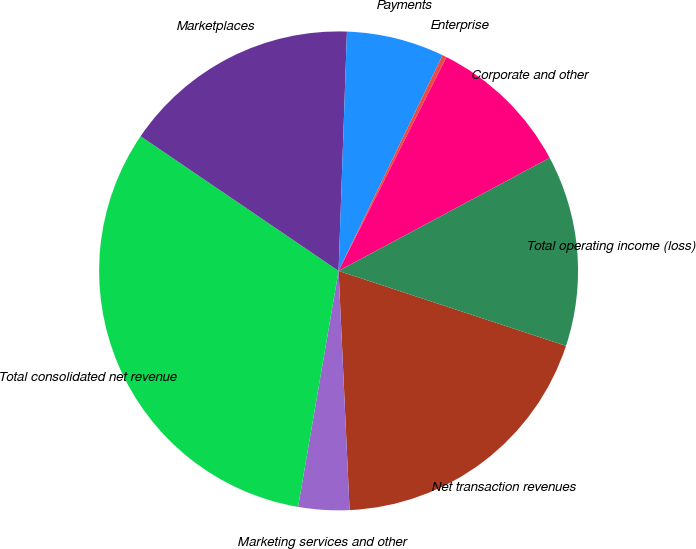<chart> <loc_0><loc_0><loc_500><loc_500><pie_chart><fcel>Net transaction revenues<fcel>Marketing services and other<fcel>Total consolidated net revenue<fcel>Marketplaces<fcel>Payments<fcel>Enterprise<fcel>Corporate and other<fcel>Total operating income (loss)<nl><fcel>19.2%<fcel>3.44%<fcel>31.8%<fcel>16.05%<fcel>6.59%<fcel>0.29%<fcel>9.74%<fcel>12.89%<nl></chart> 